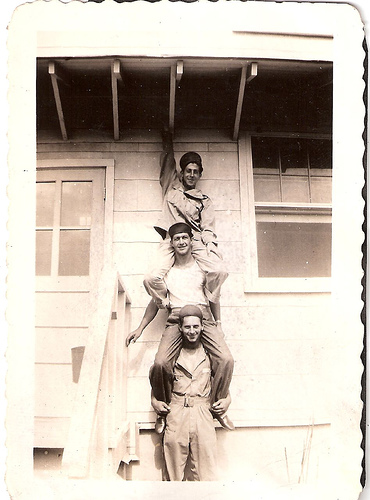<image>
Is the man behind the man? No. The man is not behind the man. From this viewpoint, the man appears to be positioned elsewhere in the scene. 